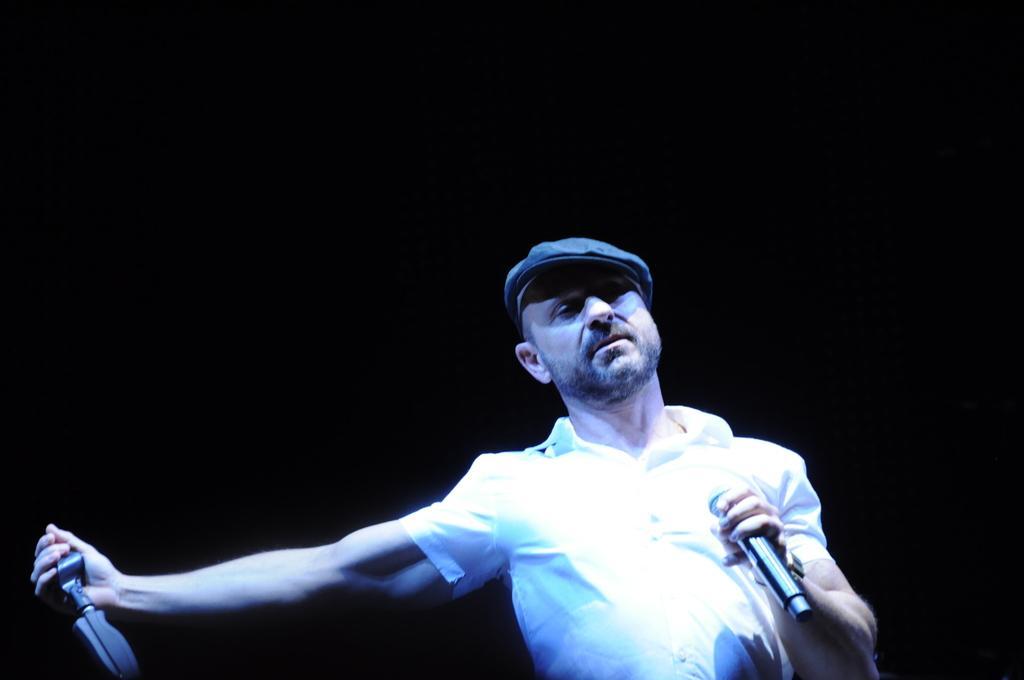Describe this image in one or two sentences. This is the picture of a person who wore a white shirt and a hat holding the mike in the left hand and some thing in his right hand with the background of black color. 